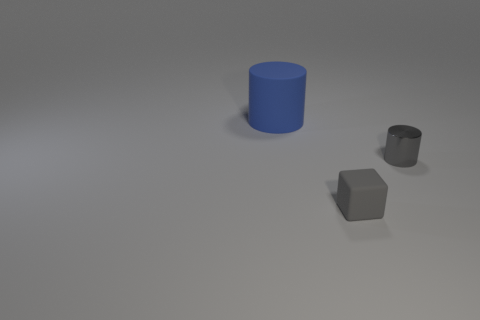What is the color of the matte thing in front of the gray object on the right side of the rubber object that is on the right side of the large rubber object?
Offer a very short reply. Gray. Do the cylinder in front of the big thing and the gray object left of the metallic thing have the same material?
Give a very brief answer. No. What shape is the gray object that is left of the gray metal cylinder?
Make the answer very short. Cube. What number of objects are yellow matte objects or cylinders in front of the matte cylinder?
Offer a very short reply. 1. Do the big blue thing and the block have the same material?
Offer a very short reply. Yes. Are there the same number of cylinders behind the big rubber cylinder and small cylinders that are behind the tiny rubber thing?
Make the answer very short. No. There is a tiny shiny cylinder; what number of tiny gray metal objects are left of it?
Offer a terse response. 0. What number of things are large red matte blocks or tiny gray matte things?
Make the answer very short. 1. How many metallic objects are the same size as the gray matte object?
Ensure brevity in your answer.  1. There is a thing that is behind the thing to the right of the rubber block; what shape is it?
Your response must be concise. Cylinder. 